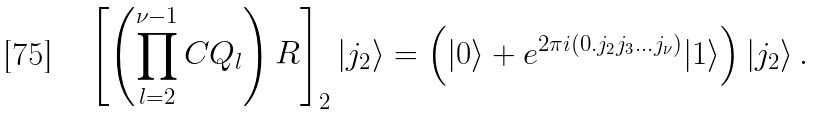<formula> <loc_0><loc_0><loc_500><loc_500>\left [ \left ( \prod _ { l = 2 } ^ { \nu - 1 } C { Q } _ { l } \right ) { R } \right ] _ { 2 } | j _ { 2 } \rangle = \left ( | 0 \rangle + e ^ { 2 \pi i ( 0 . j _ { 2 } j _ { 3 } \dots j _ { \nu } ) } | 1 \rangle \right ) | j _ { 2 } \rangle \, .</formula> 